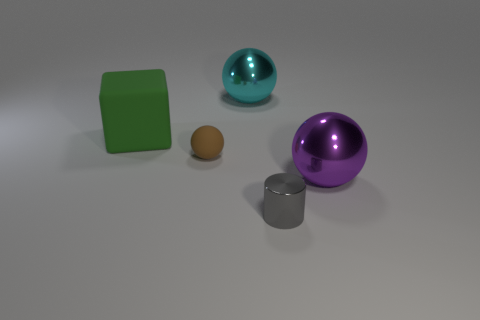Imagine these objects are part of a set for a child's game. Can you come up with a simple game that could be played with these? Absolutely. A possible game could involve color and shape matching. The child could use the various objects to match colors and shapes that are shown on cards. For example, a card could show a purple ball, and they'd have to pick up the purple ball. What skills might this game help a child develop? This game could help develop a child's motor skills through object manipulation, as well as cognitive skills such as color and shape recognition, memory, and problem-solving. 